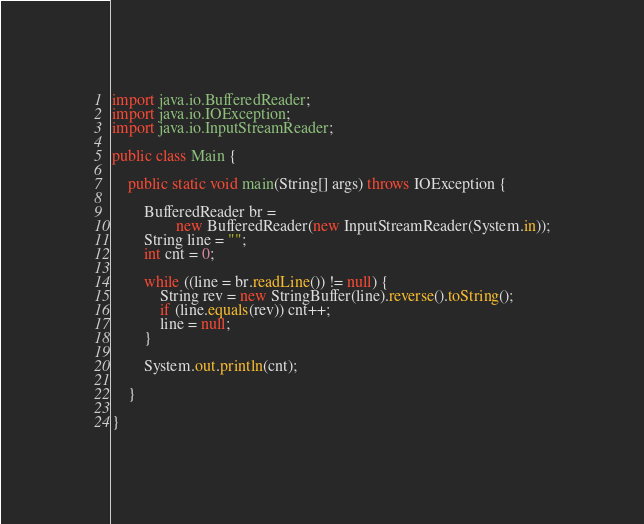<code> <loc_0><loc_0><loc_500><loc_500><_Java_>import java.io.BufferedReader;
import java.io.IOException;
import java.io.InputStreamReader;

public class Main {

	public static void main(String[] args) throws IOException {

		BufferedReader br =
				new BufferedReader(new InputStreamReader(System.in));
		String line = "";
		int cnt = 0;

		while ((line = br.readLine()) != null) {
			String rev = new StringBuffer(line).reverse().toString();
			if (line.equals(rev)) cnt++;
			line = null;
		}

		System.out.println(cnt);

	}

}</code> 